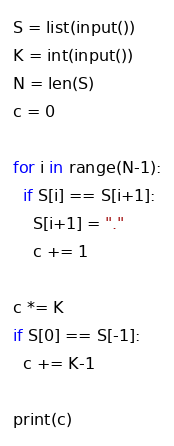<code> <loc_0><loc_0><loc_500><loc_500><_Python_>S = list(input())
K = int(input())
N = len(S)
c = 0

for i in range(N-1):
  if S[i] == S[i+1]:
    S[i+1] = "."
    c += 1
    
c *= K
if S[0] == S[-1]:
  c += K-1
  
print(c)</code> 